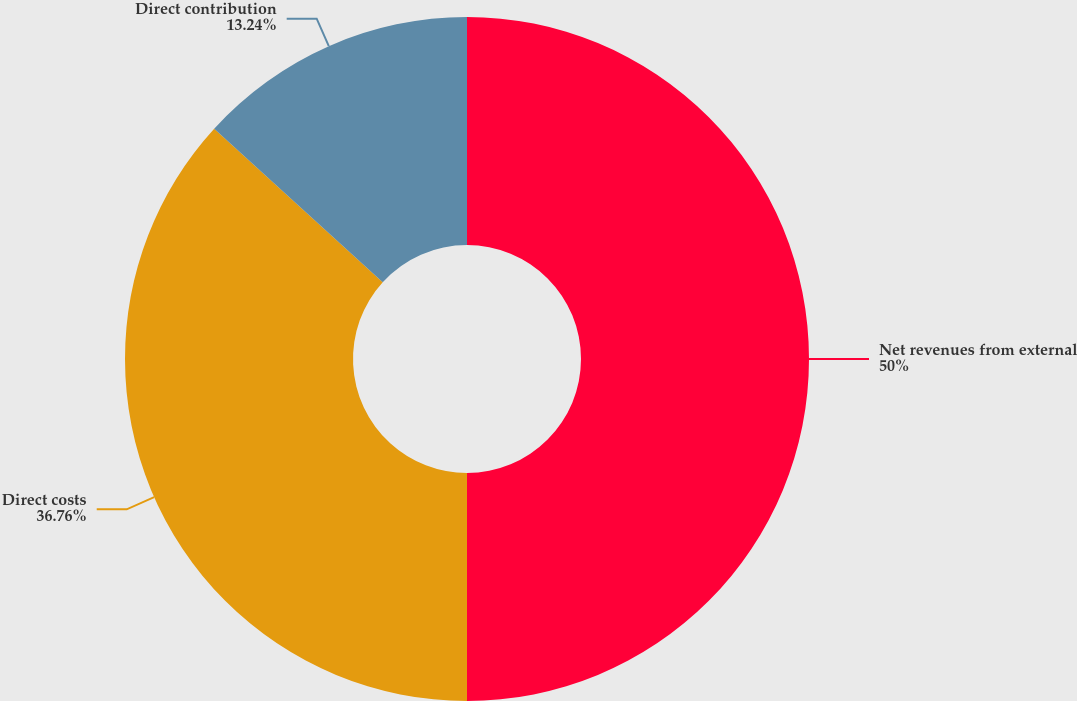<chart> <loc_0><loc_0><loc_500><loc_500><pie_chart><fcel>Net revenues from external<fcel>Direct costs<fcel>Direct contribution<nl><fcel>50.0%<fcel>36.76%<fcel>13.24%<nl></chart> 